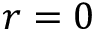<formula> <loc_0><loc_0><loc_500><loc_500>r = 0</formula> 